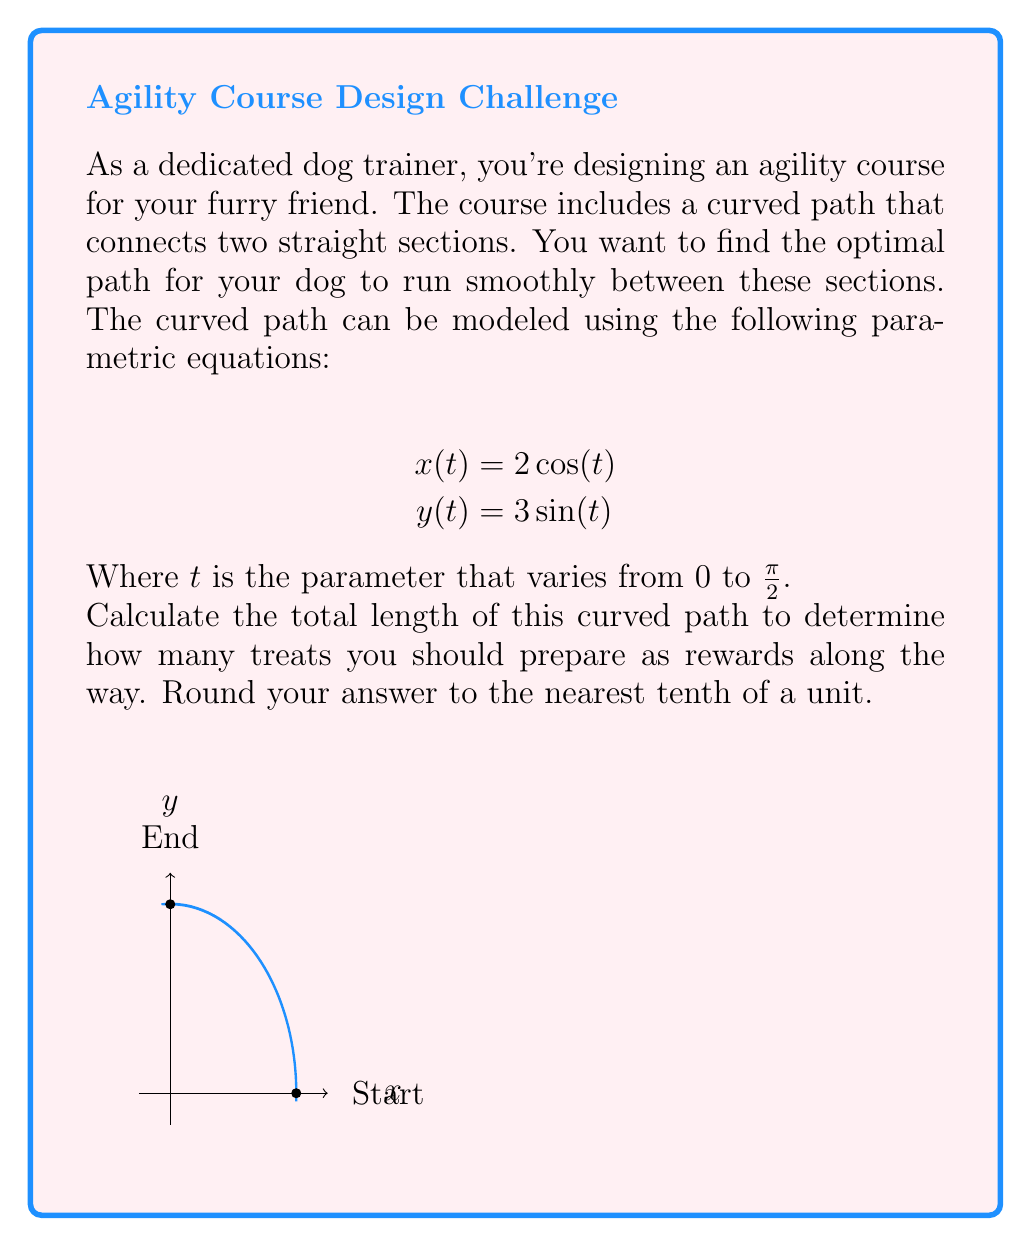Teach me how to tackle this problem. To find the length of the curved path, we need to use the arc length formula for parametric equations:

$$L = \int_a^b \sqrt{\left(\frac{dx}{dt}\right)^2 + \left(\frac{dy}{dt}\right)^2} dt$$

Step 1: Find $\frac{dx}{dt}$ and $\frac{dy}{dt}$
$$\frac{dx}{dt} = -2\sin(t)$$
$$\frac{dy}{dt} = 3\cos(t)$$

Step 2: Substitute these into the arc length formula
$$L = \int_0^{\frac{\pi}{2}} \sqrt{(-2\sin(t))^2 + (3\cos(t))^2} dt$$

Step 3: Simplify the expression under the square root
$$L = \int_0^{\frac{\pi}{2}} \sqrt{4\sin^2(t) + 9\cos^2(t)} dt$$

Step 4: Use the trigonometric identity $\sin^2(t) + \cos^2(t) = 1$ to simplify further
$$L = \int_0^{\frac{\pi}{2}} \sqrt{4(1-\cos^2(t)) + 9\cos^2(t)} dt$$
$$L = \int_0^{\frac{\pi}{2}} \sqrt{4 + 5\cos^2(t)} dt$$

Step 5: This integral doesn't have an elementary antiderivative, so we need to use numerical integration. Using a computer algebra system or calculator, we get:

$$L \approx 3.9362$$

Step 6: Rounding to the nearest tenth:
$$L \approx 3.9$$
Answer: 3.9 units 